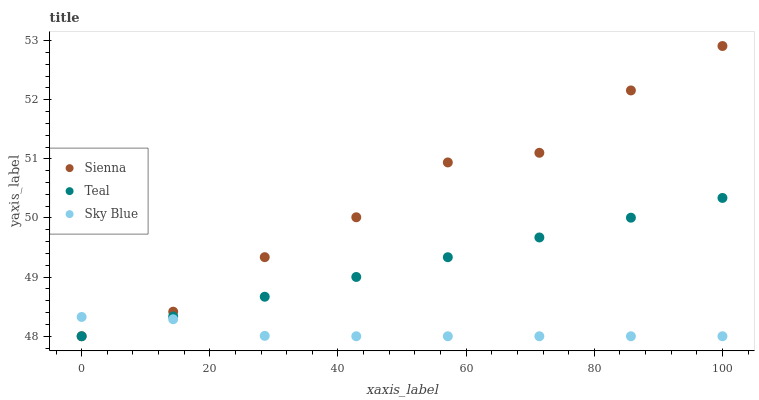Does Sky Blue have the minimum area under the curve?
Answer yes or no. Yes. Does Sienna have the maximum area under the curve?
Answer yes or no. Yes. Does Teal have the minimum area under the curve?
Answer yes or no. No. Does Teal have the maximum area under the curve?
Answer yes or no. No. Is Teal the smoothest?
Answer yes or no. Yes. Is Sienna the roughest?
Answer yes or no. Yes. Is Sky Blue the smoothest?
Answer yes or no. No. Is Sky Blue the roughest?
Answer yes or no. No. Does Sienna have the lowest value?
Answer yes or no. Yes. Does Sienna have the highest value?
Answer yes or no. Yes. Does Teal have the highest value?
Answer yes or no. No. Does Teal intersect Sienna?
Answer yes or no. Yes. Is Teal less than Sienna?
Answer yes or no. No. Is Teal greater than Sienna?
Answer yes or no. No. 